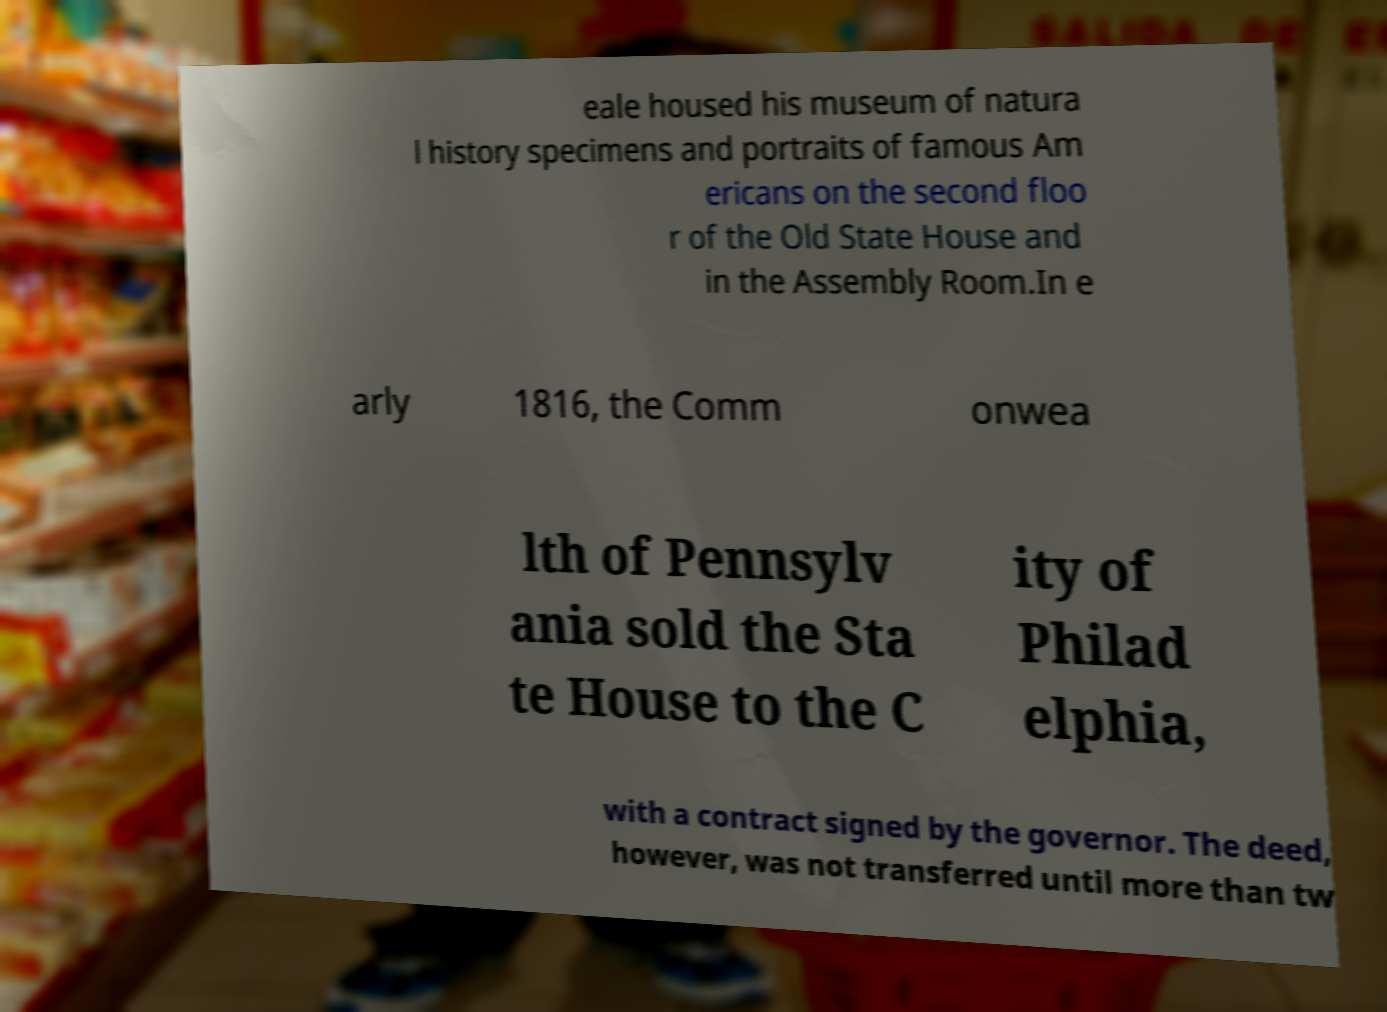I need the written content from this picture converted into text. Can you do that? eale housed his museum of natura l history specimens and portraits of famous Am ericans on the second floo r of the Old State House and in the Assembly Room.In e arly 1816, the Comm onwea lth of Pennsylv ania sold the Sta te House to the C ity of Philad elphia, with a contract signed by the governor. The deed, however, was not transferred until more than tw 